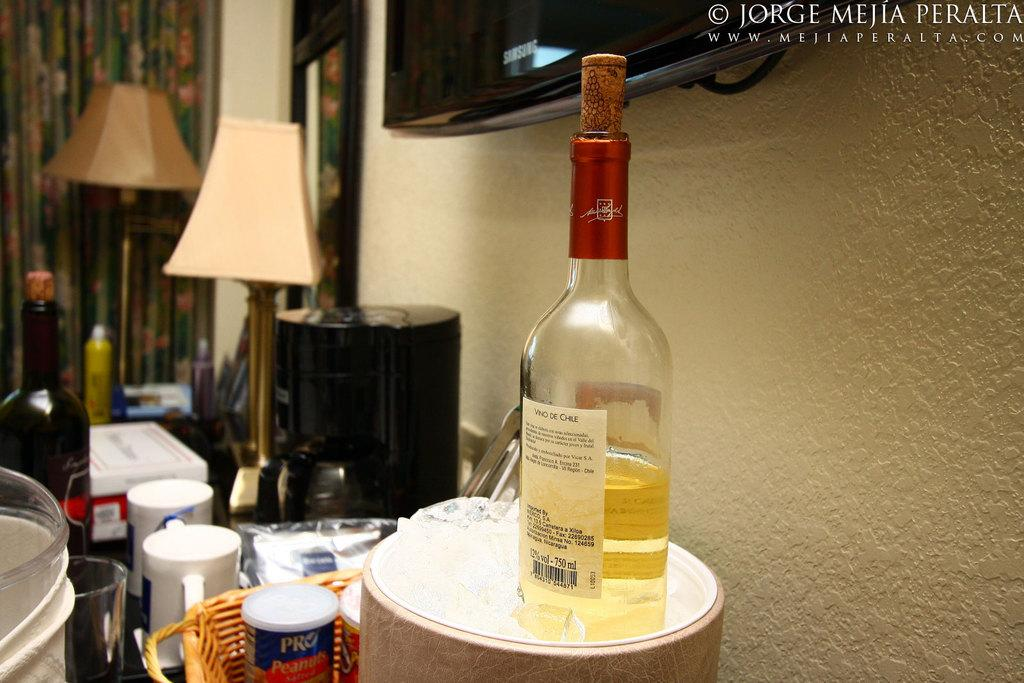What type of container is visible in the image? There is a bottle, a glass, and a jar in the image. What other objects can be seen in the image? There is a basket and a lamp in the image. What is visible in the background of the image? There is a wall, a television, and a curtain in the background of the image. What experience does the sister have with the appliance in the image? There is no sister or appliance present in the image. 